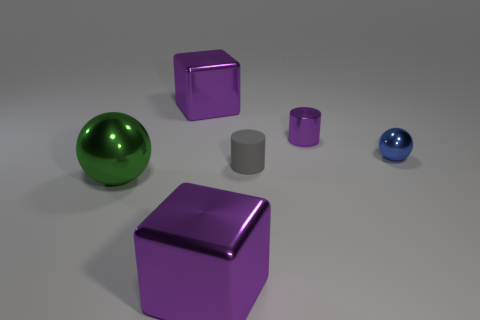There is a large purple object that is in front of the matte object; is its shape the same as the green thing?
Offer a terse response. No. What material is the blue thing?
Provide a short and direct response. Metal. What shape is the blue shiny thing that is the same size as the matte cylinder?
Make the answer very short. Sphere. Are there any rubber objects of the same color as the matte cylinder?
Provide a succinct answer. No. Is the color of the big metal ball the same as the ball on the right side of the gray rubber cylinder?
Your answer should be very brief. No. What color is the sphere that is in front of the small metal sphere that is on the right side of the green shiny thing?
Your answer should be very brief. Green. There is a shiny ball that is right of the big purple thing in front of the metal cylinder; are there any small matte objects to the right of it?
Offer a terse response. No. The large sphere that is the same material as the blue thing is what color?
Provide a succinct answer. Green. What number of cylinders are the same material as the tiny blue object?
Offer a very short reply. 1. Is the material of the small blue sphere the same as the big purple object that is in front of the blue shiny object?
Offer a terse response. Yes. 